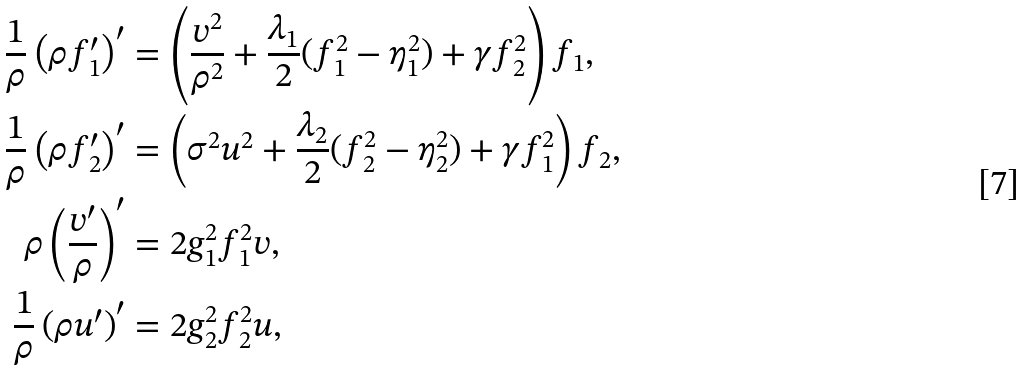<formula> <loc_0><loc_0><loc_500><loc_500>\frac { 1 } { \rho } \left ( \rho f _ { 1 } ^ { \prime } \right ) ^ { \prime } & = \left ( \frac { v ^ { 2 } } { \rho ^ { 2 } } + \frac { \lambda _ { 1 } } { 2 } ( f _ { 1 } ^ { 2 } - \eta _ { 1 } ^ { 2 } ) + \gamma f _ { 2 } ^ { 2 } \right ) f _ { 1 } , \\ \frac { 1 } { \rho } \left ( \rho f _ { 2 } ^ { \prime } \right ) ^ { \prime } & = \left ( \sigma ^ { 2 } u ^ { 2 } + \frac { \lambda _ { 2 } } { 2 } ( f _ { 2 } ^ { 2 } - \eta _ { 2 } ^ { 2 } ) + \gamma f _ { 1 } ^ { 2 } \right ) f _ { 2 } , \\ \rho \left ( \frac { v ^ { \prime } } { \rho } \right ) ^ { \prime } & = 2 g _ { 1 } ^ { 2 } f _ { 1 } ^ { 2 } v , \\ \frac { 1 } { \rho } \left ( \rho u ^ { \prime } \right ) ^ { \prime } & = 2 g _ { 2 } ^ { 2 } f _ { 2 } ^ { 2 } u ,</formula> 